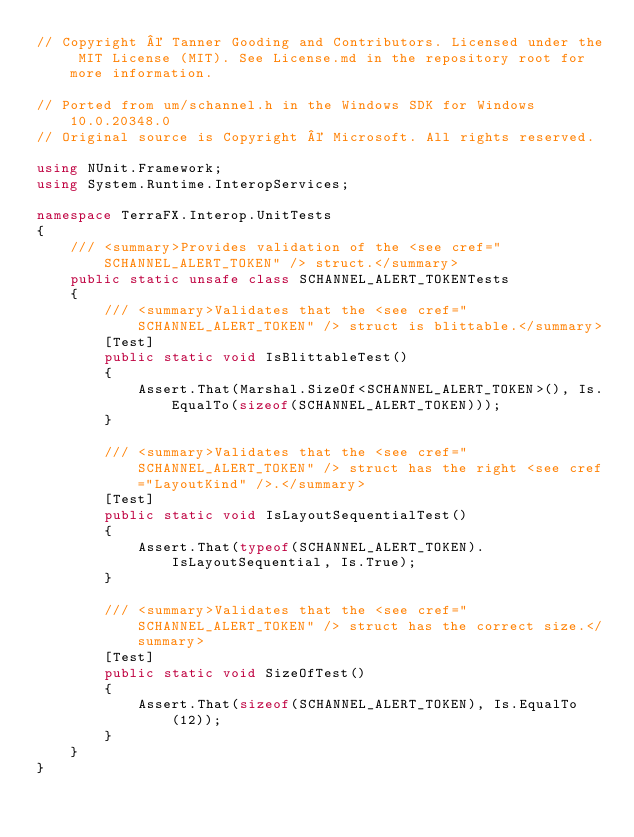<code> <loc_0><loc_0><loc_500><loc_500><_C#_>// Copyright © Tanner Gooding and Contributors. Licensed under the MIT License (MIT). See License.md in the repository root for more information.

// Ported from um/schannel.h in the Windows SDK for Windows 10.0.20348.0
// Original source is Copyright © Microsoft. All rights reserved.

using NUnit.Framework;
using System.Runtime.InteropServices;

namespace TerraFX.Interop.UnitTests
{
    /// <summary>Provides validation of the <see cref="SCHANNEL_ALERT_TOKEN" /> struct.</summary>
    public static unsafe class SCHANNEL_ALERT_TOKENTests
    {
        /// <summary>Validates that the <see cref="SCHANNEL_ALERT_TOKEN" /> struct is blittable.</summary>
        [Test]
        public static void IsBlittableTest()
        {
            Assert.That(Marshal.SizeOf<SCHANNEL_ALERT_TOKEN>(), Is.EqualTo(sizeof(SCHANNEL_ALERT_TOKEN)));
        }

        /// <summary>Validates that the <see cref="SCHANNEL_ALERT_TOKEN" /> struct has the right <see cref="LayoutKind" />.</summary>
        [Test]
        public static void IsLayoutSequentialTest()
        {
            Assert.That(typeof(SCHANNEL_ALERT_TOKEN).IsLayoutSequential, Is.True);
        }

        /// <summary>Validates that the <see cref="SCHANNEL_ALERT_TOKEN" /> struct has the correct size.</summary>
        [Test]
        public static void SizeOfTest()
        {
            Assert.That(sizeof(SCHANNEL_ALERT_TOKEN), Is.EqualTo(12));
        }
    }
}
</code> 